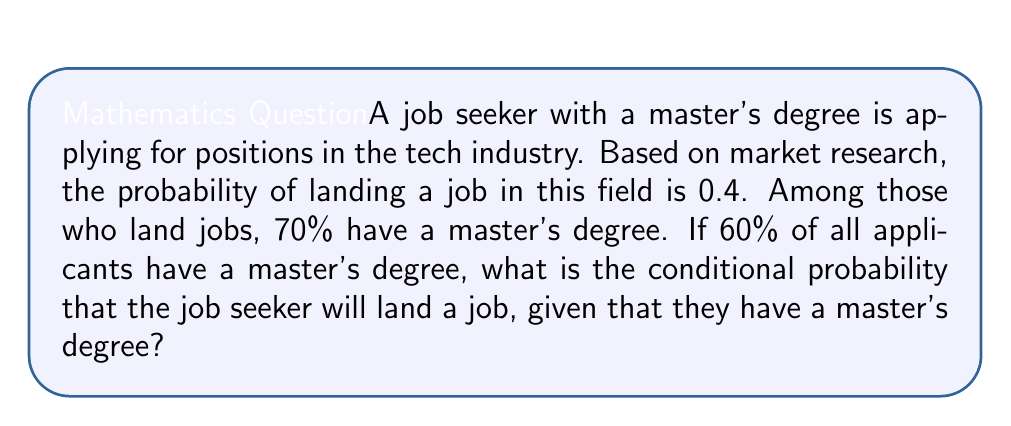Could you help me with this problem? Let's approach this step-by-step using Bayes' theorem:

1) Define events:
   A: Landing a job
   B: Having a master's degree

2) Given probabilities:
   P(A) = 0.4 (probability of landing a job)
   P(B|A) = 0.7 (probability of having a master's degree given that one landed a job)
   P(B) = 0.6 (probability of having a master's degree among all applicants)

3) We need to find P(A|B) using Bayes' theorem:

   $$P(A|B) = \frac{P(B|A) \cdot P(A)}{P(B)}$$

4) Substituting the values:

   $$P(A|B) = \frac{0.7 \cdot 0.4}{0.6}$$

5) Calculating:

   $$P(A|B) = \frac{0.28}{0.6} = \frac{14}{30} = \frac{7}{15} \approx 0.4667$$

Thus, the conditional probability of landing a job given that the applicant has a master's degree is approximately 0.4667 or 46.67%.
Answer: $\frac{7}{15}$ or approximately 0.4667 